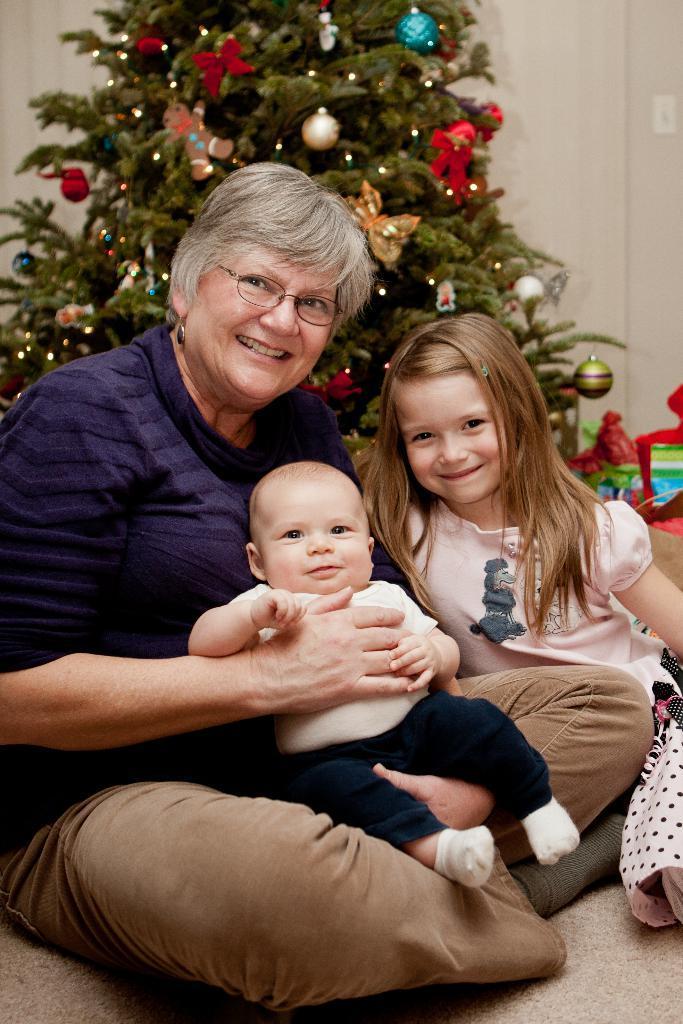Could you give a brief overview of what you see in this image? In this picture we can see a woman and two kids, behind them we can find a Christmas tree, lights and decorative things. 